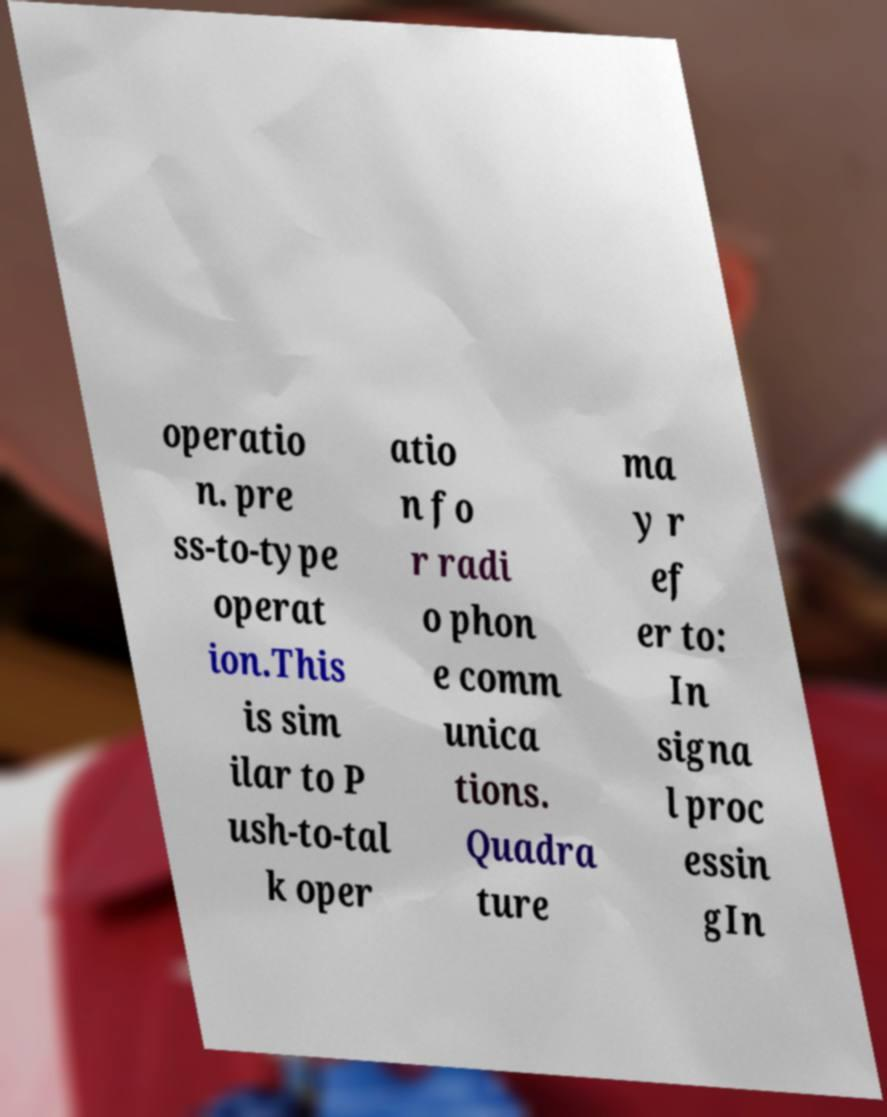Could you extract and type out the text from this image? operatio n. pre ss-to-type operat ion.This is sim ilar to P ush-to-tal k oper atio n fo r radi o phon e comm unica tions. Quadra ture ma y r ef er to: In signa l proc essin gIn 